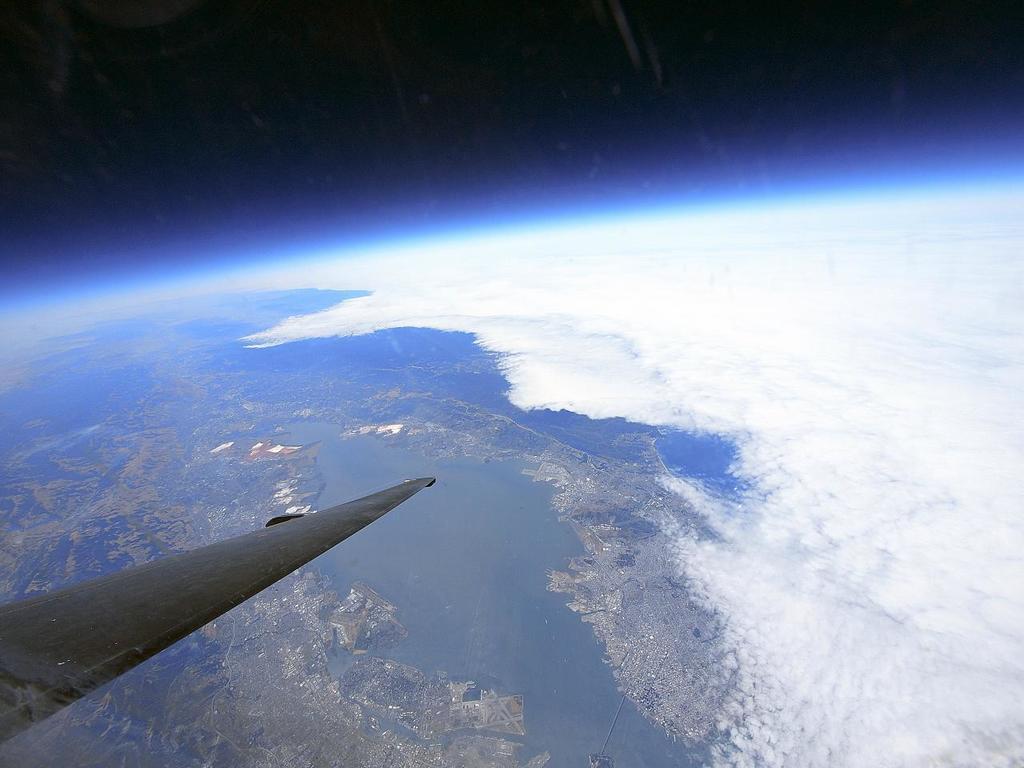How would you summarize this image in a sentence or two? In the bottom left corner I can see the plane's wings which is flying in the sky. In the background I can see the water, city, clouds and trees. At the top I can see the sky. 